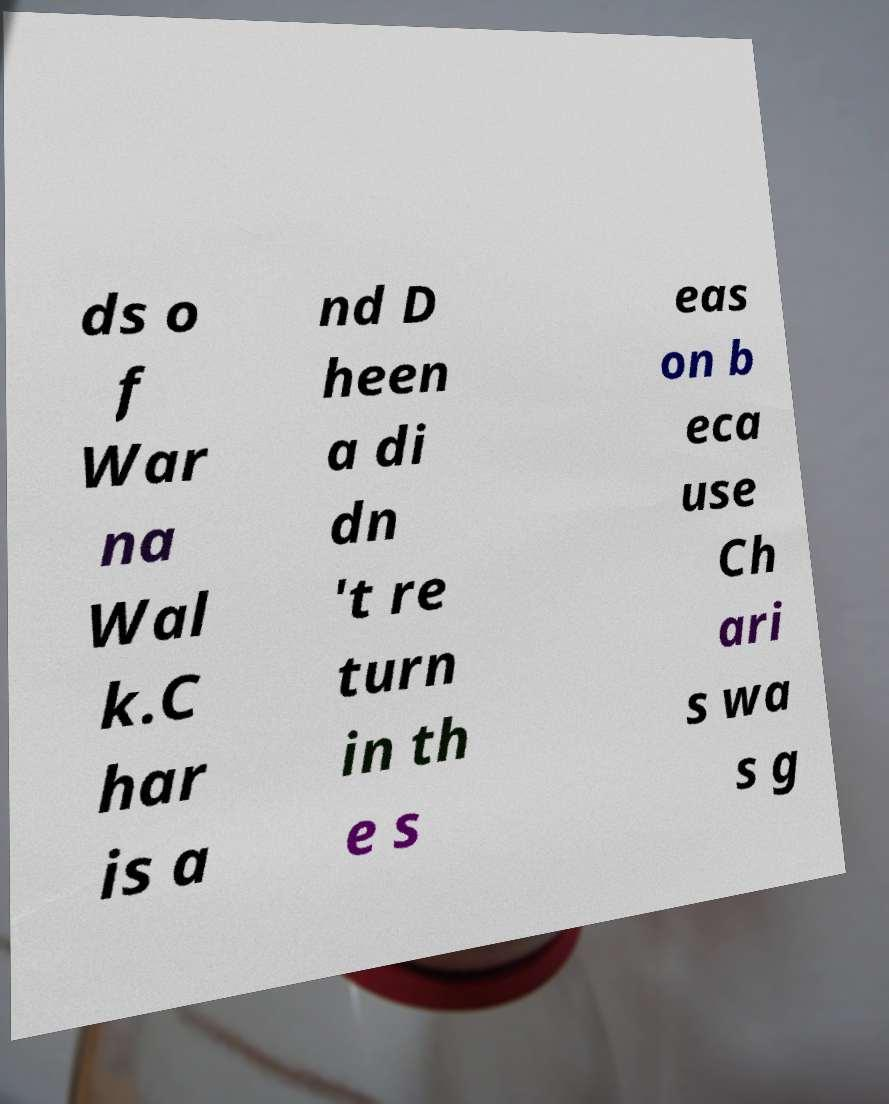Please identify and transcribe the text found in this image. ds o f War na Wal k.C har is a nd D heen a di dn 't re turn in th e s eas on b eca use Ch ari s wa s g 